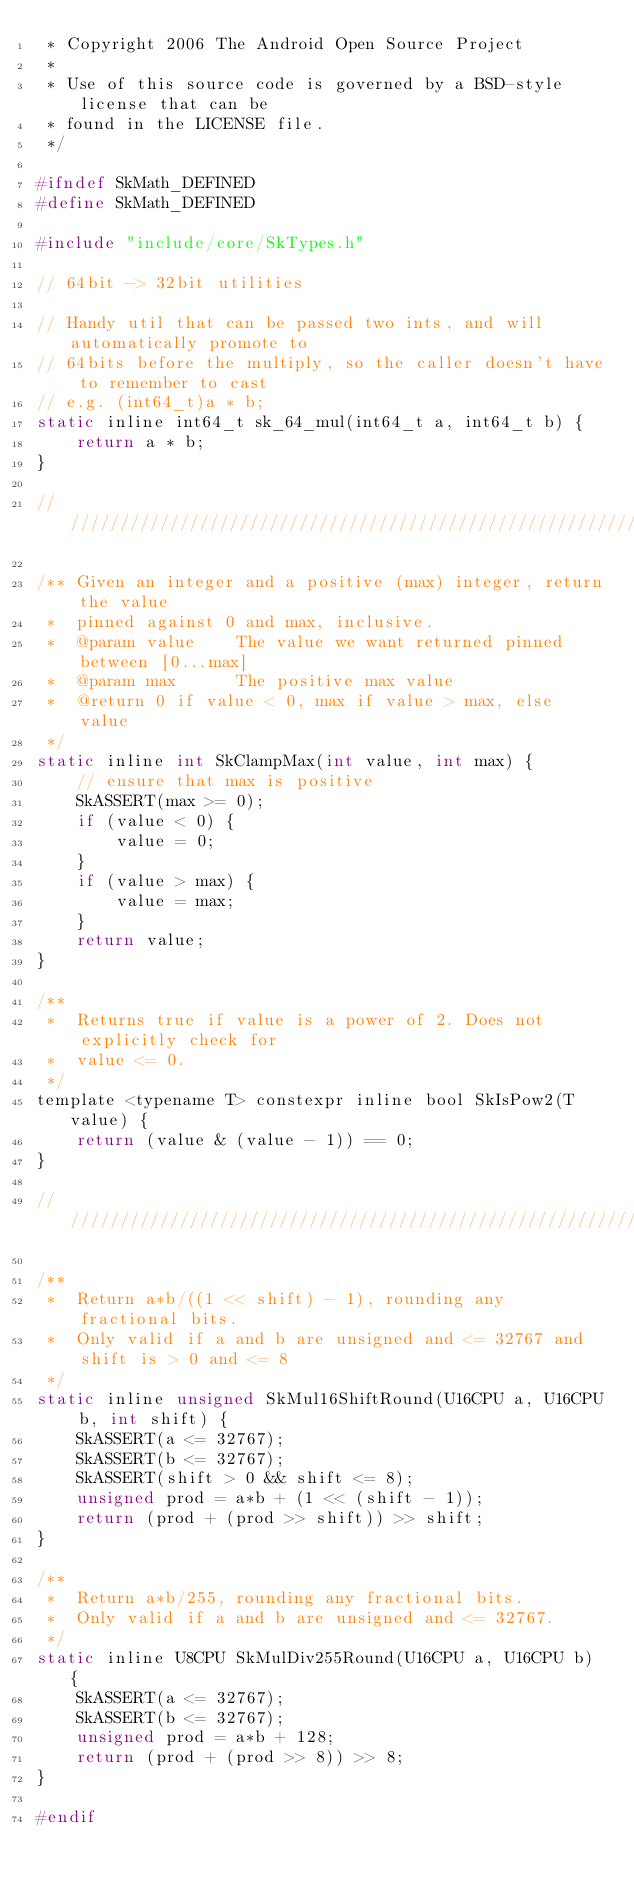<code> <loc_0><loc_0><loc_500><loc_500><_C_> * Copyright 2006 The Android Open Source Project
 *
 * Use of this source code is governed by a BSD-style license that can be
 * found in the LICENSE file.
 */

#ifndef SkMath_DEFINED
#define SkMath_DEFINED

#include "include/core/SkTypes.h"

// 64bit -> 32bit utilities

// Handy util that can be passed two ints, and will automatically promote to
// 64bits before the multiply, so the caller doesn't have to remember to cast
// e.g. (int64_t)a * b;
static inline int64_t sk_64_mul(int64_t a, int64_t b) {
    return a * b;
}

///////////////////////////////////////////////////////////////////////////////

/** Given an integer and a positive (max) integer, return the value
 *  pinned against 0 and max, inclusive.
 *  @param value    The value we want returned pinned between [0...max]
 *  @param max      The positive max value
 *  @return 0 if value < 0, max if value > max, else value
 */
static inline int SkClampMax(int value, int max) {
    // ensure that max is positive
    SkASSERT(max >= 0);
    if (value < 0) {
        value = 0;
    }
    if (value > max) {
        value = max;
    }
    return value;
}

/**
 *  Returns true if value is a power of 2. Does not explicitly check for
 *  value <= 0.
 */
template <typename T> constexpr inline bool SkIsPow2(T value) {
    return (value & (value - 1)) == 0;
}

///////////////////////////////////////////////////////////////////////////////

/**
 *  Return a*b/((1 << shift) - 1), rounding any fractional bits.
 *  Only valid if a and b are unsigned and <= 32767 and shift is > 0 and <= 8
 */
static inline unsigned SkMul16ShiftRound(U16CPU a, U16CPU b, int shift) {
    SkASSERT(a <= 32767);
    SkASSERT(b <= 32767);
    SkASSERT(shift > 0 && shift <= 8);
    unsigned prod = a*b + (1 << (shift - 1));
    return (prod + (prod >> shift)) >> shift;
}

/**
 *  Return a*b/255, rounding any fractional bits.
 *  Only valid if a and b are unsigned and <= 32767.
 */
static inline U8CPU SkMulDiv255Round(U16CPU a, U16CPU b) {
    SkASSERT(a <= 32767);
    SkASSERT(b <= 32767);
    unsigned prod = a*b + 128;
    return (prod + (prod >> 8)) >> 8;
}

#endif
</code> 